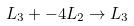Convert formula to latex. <formula><loc_0><loc_0><loc_500><loc_500>L _ { 3 } + - 4 L _ { 2 } \rightarrow L _ { 3 }</formula> 